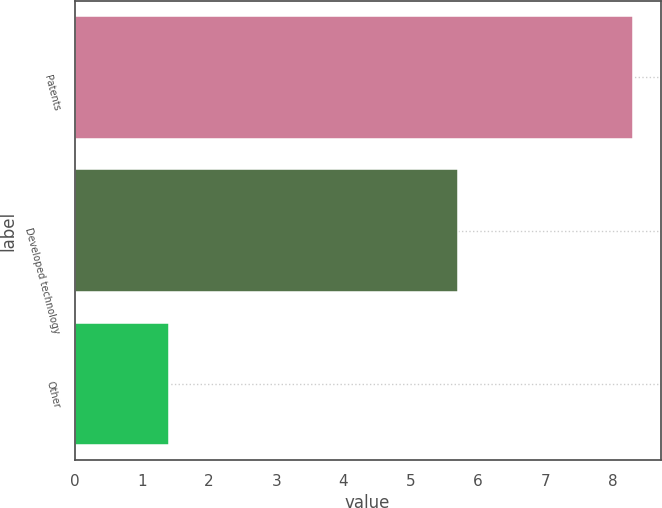<chart> <loc_0><loc_0><loc_500><loc_500><bar_chart><fcel>Patents<fcel>Developed technology<fcel>Other<nl><fcel>8.3<fcel>5.7<fcel>1.4<nl></chart> 